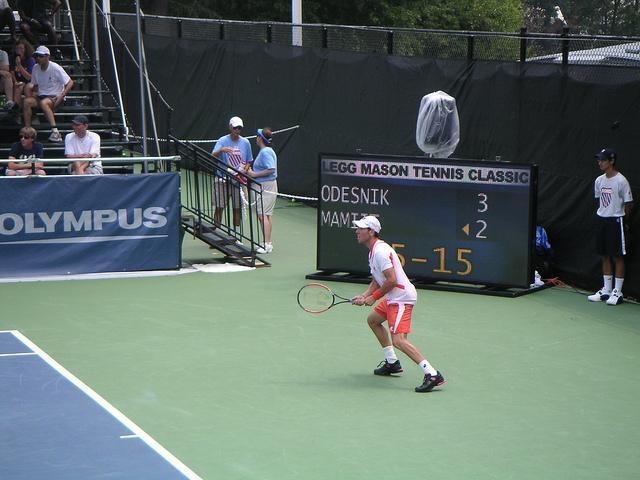What type of tennis game is being played here?
Indicate the correct response by choosing from the four available options to answer the question.
Options: Doubles, singles, handball, mixed doubles. Singles. 